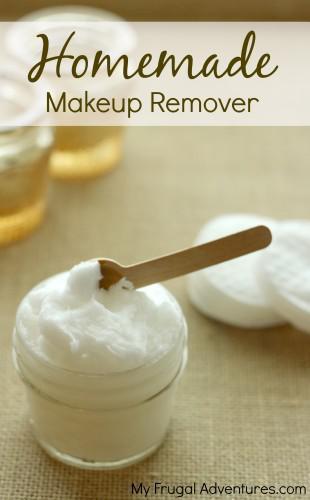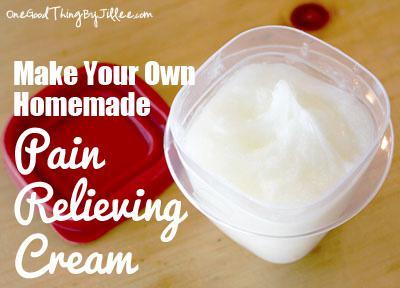The first image is the image on the left, the second image is the image on the right. Evaluate the accuracy of this statement regarding the images: "There are no spoons or spatulas in any of the images.". Is it true? Answer yes or no. No. The first image is the image on the left, the second image is the image on the right. Evaluate the accuracy of this statement regarding the images: "None of the creams are green.". Is it true? Answer yes or no. Yes. 